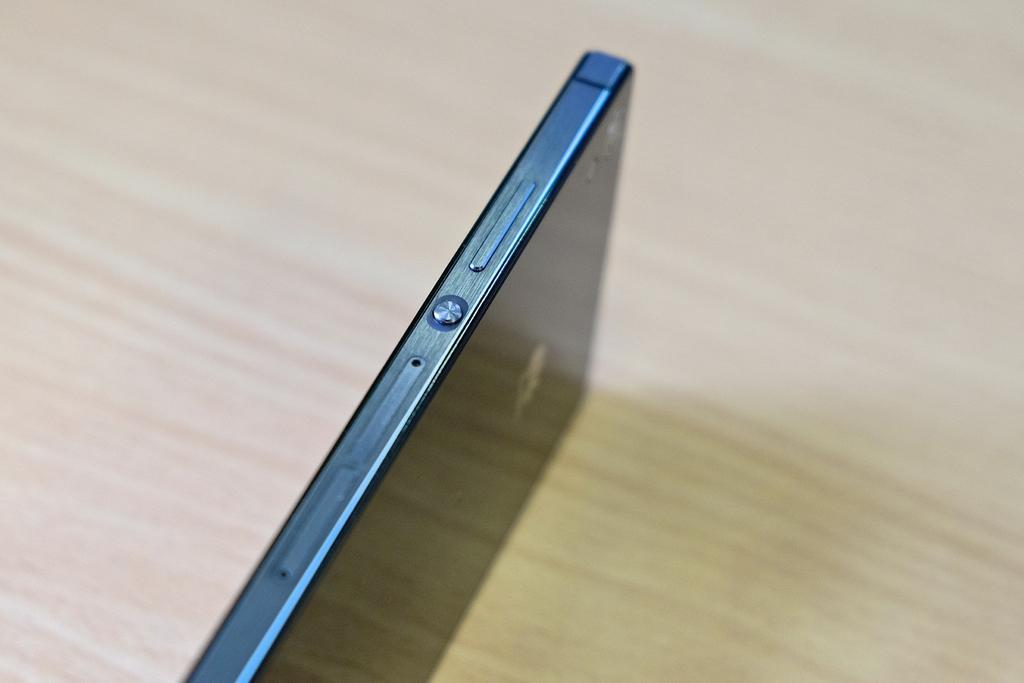Can you describe this image briefly? In this image we can see a mobile phone on the surface. 